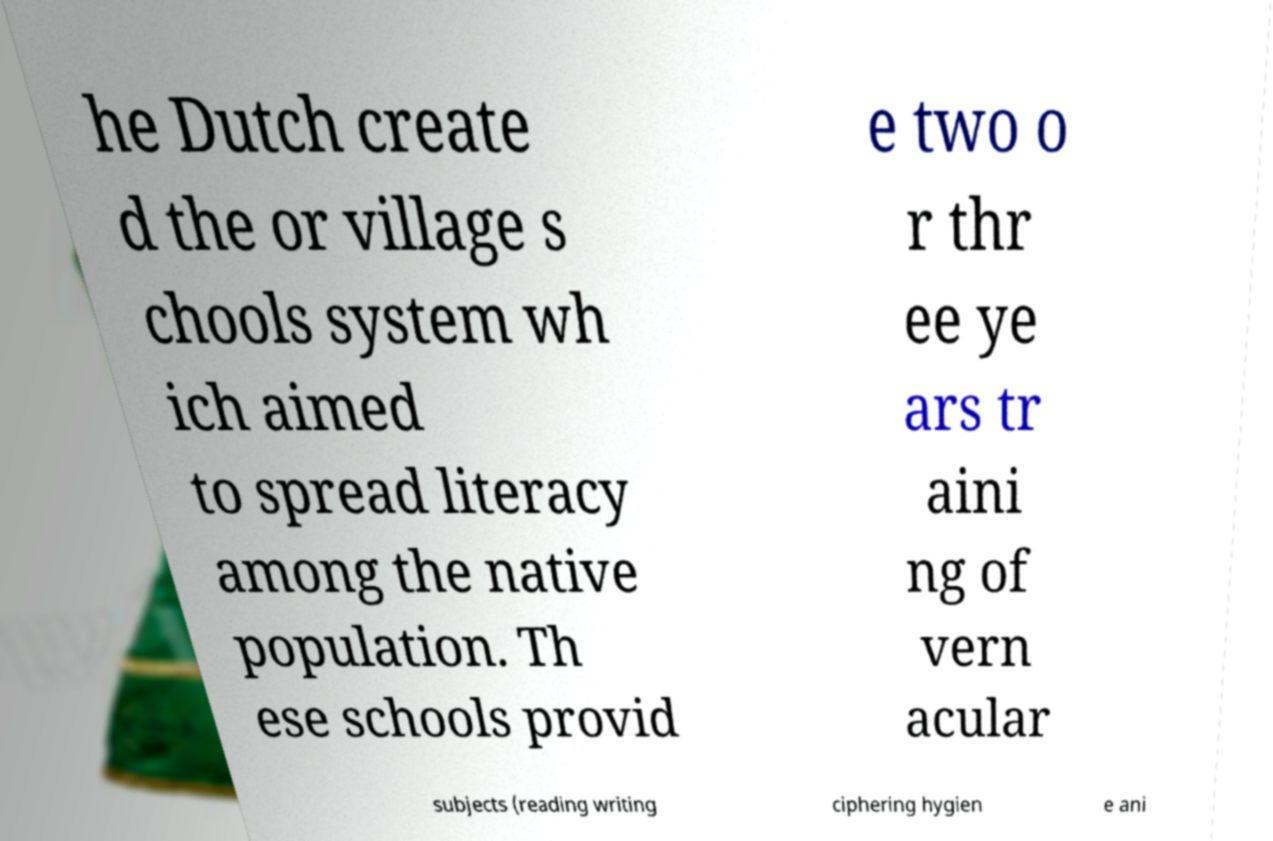Could you extract and type out the text from this image? he Dutch create d the or village s chools system wh ich aimed to spread literacy among the native population. Th ese schools provid e two o r thr ee ye ars tr aini ng of vern acular subjects (reading writing ciphering hygien e ani 